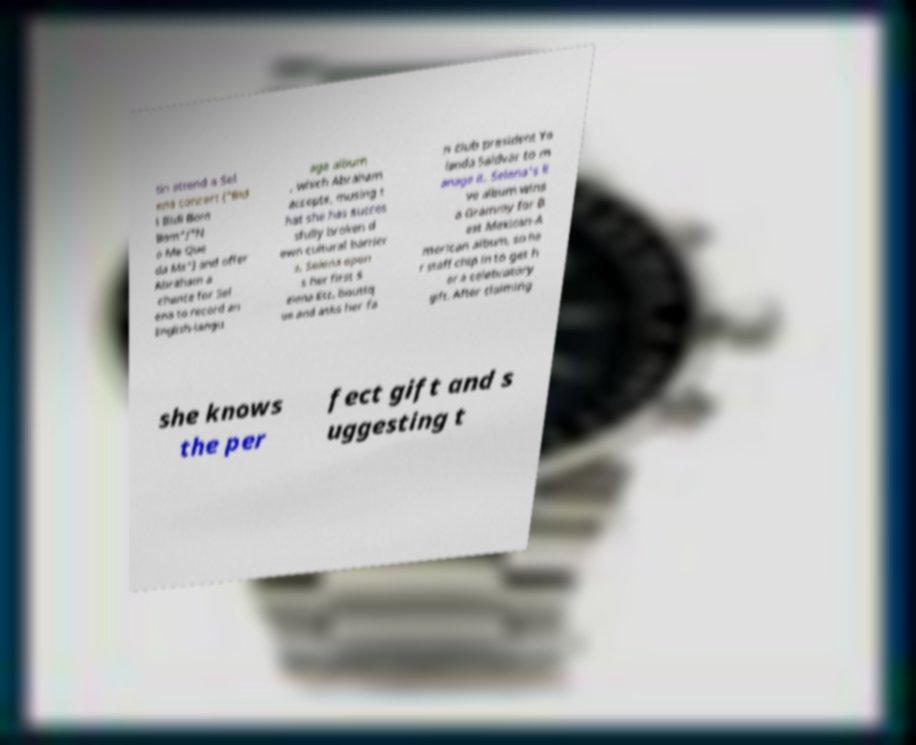Can you read and provide the text displayed in the image?This photo seems to have some interesting text. Can you extract and type it out for me? tin attend a Sel ena concert ("Bid i Bidi Bom Bom"/"N o Me Que da Ms") and offer Abraham a chance for Sel ena to record an English-langu age album , which Abraham accepts, musing t hat she has succes sfully broken d own cultural barrier s. Selena open s her first S elena Etc. boutiq ue and asks her fa n club president Yo landa Saldvar to m anage it. Selena's li ve album wins a Grammy for B est Mexican-A merican album, so he r staff chip in to get h er a celebratory gift. After claiming she knows the per fect gift and s uggesting t 